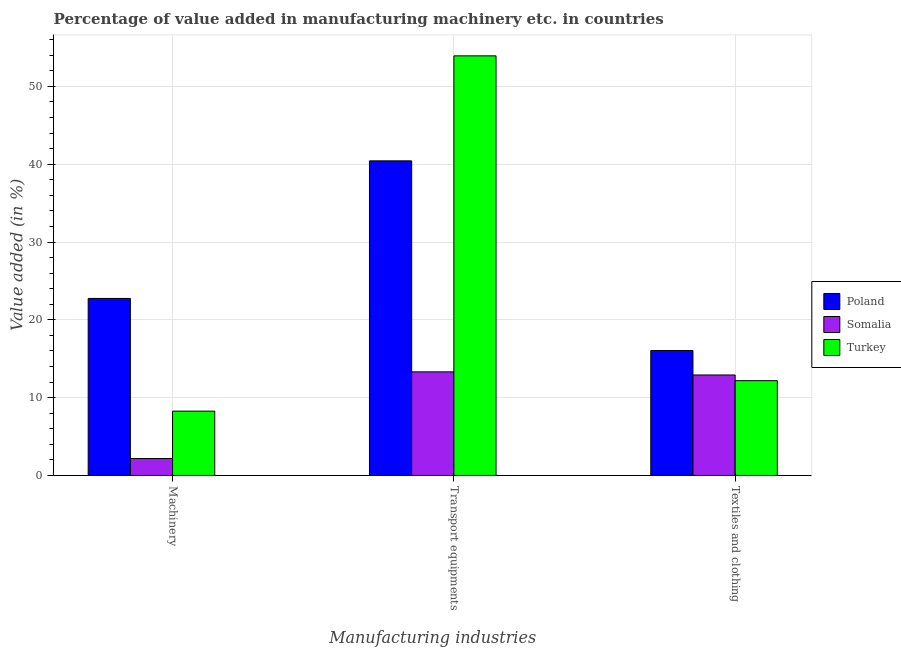Are the number of bars per tick equal to the number of legend labels?
Ensure brevity in your answer.  Yes. How many bars are there on the 3rd tick from the left?
Ensure brevity in your answer.  3. What is the label of the 3rd group of bars from the left?
Make the answer very short. Textiles and clothing. What is the value added in manufacturing machinery in Poland?
Your answer should be compact. 22.75. Across all countries, what is the maximum value added in manufacturing transport equipments?
Your answer should be compact. 53.93. Across all countries, what is the minimum value added in manufacturing transport equipments?
Give a very brief answer. 13.31. In which country was the value added in manufacturing transport equipments minimum?
Offer a terse response. Somalia. What is the total value added in manufacturing machinery in the graph?
Provide a succinct answer. 33.19. What is the difference between the value added in manufacturing transport equipments in Somalia and that in Poland?
Ensure brevity in your answer.  -27.12. What is the difference between the value added in manufacturing transport equipments in Poland and the value added in manufacturing machinery in Turkey?
Provide a succinct answer. 32.17. What is the average value added in manufacturing transport equipments per country?
Give a very brief answer. 35.89. What is the difference between the value added in manufacturing transport equipments and value added in manufacturing textile and clothing in Turkey?
Give a very brief answer. 41.75. In how many countries, is the value added in manufacturing transport equipments greater than 44 %?
Ensure brevity in your answer.  1. What is the ratio of the value added in manufacturing transport equipments in Poland to that in Turkey?
Offer a very short reply. 0.75. Is the value added in manufacturing machinery in Poland less than that in Somalia?
Offer a terse response. No. What is the difference between the highest and the second highest value added in manufacturing machinery?
Keep it short and to the point. 14.49. What is the difference between the highest and the lowest value added in manufacturing machinery?
Provide a short and direct response. 20.58. In how many countries, is the value added in manufacturing textile and clothing greater than the average value added in manufacturing textile and clothing taken over all countries?
Give a very brief answer. 1. What does the 3rd bar from the left in Transport equipments represents?
Your response must be concise. Turkey. What does the 2nd bar from the right in Textiles and clothing represents?
Offer a terse response. Somalia. Is it the case that in every country, the sum of the value added in manufacturing machinery and value added in manufacturing transport equipments is greater than the value added in manufacturing textile and clothing?
Provide a succinct answer. Yes. Are all the bars in the graph horizontal?
Your answer should be compact. No. What is the difference between two consecutive major ticks on the Y-axis?
Ensure brevity in your answer.  10. Does the graph contain grids?
Offer a very short reply. Yes. What is the title of the graph?
Provide a short and direct response. Percentage of value added in manufacturing machinery etc. in countries. What is the label or title of the X-axis?
Your answer should be compact. Manufacturing industries. What is the label or title of the Y-axis?
Your response must be concise. Value added (in %). What is the Value added (in %) of Poland in Machinery?
Give a very brief answer. 22.75. What is the Value added (in %) in Somalia in Machinery?
Your answer should be very brief. 2.17. What is the Value added (in %) in Turkey in Machinery?
Keep it short and to the point. 8.27. What is the Value added (in %) of Poland in Transport equipments?
Provide a short and direct response. 40.43. What is the Value added (in %) in Somalia in Transport equipments?
Ensure brevity in your answer.  13.31. What is the Value added (in %) in Turkey in Transport equipments?
Your response must be concise. 53.93. What is the Value added (in %) in Poland in Textiles and clothing?
Provide a succinct answer. 16.05. What is the Value added (in %) of Somalia in Textiles and clothing?
Give a very brief answer. 12.91. What is the Value added (in %) in Turkey in Textiles and clothing?
Keep it short and to the point. 12.18. Across all Manufacturing industries, what is the maximum Value added (in %) in Poland?
Your answer should be compact. 40.43. Across all Manufacturing industries, what is the maximum Value added (in %) of Somalia?
Your answer should be compact. 13.31. Across all Manufacturing industries, what is the maximum Value added (in %) in Turkey?
Make the answer very short. 53.93. Across all Manufacturing industries, what is the minimum Value added (in %) in Poland?
Provide a succinct answer. 16.05. Across all Manufacturing industries, what is the minimum Value added (in %) of Somalia?
Offer a terse response. 2.17. Across all Manufacturing industries, what is the minimum Value added (in %) in Turkey?
Ensure brevity in your answer.  8.27. What is the total Value added (in %) in Poland in the graph?
Ensure brevity in your answer.  79.24. What is the total Value added (in %) in Somalia in the graph?
Provide a short and direct response. 28.4. What is the total Value added (in %) in Turkey in the graph?
Keep it short and to the point. 74.37. What is the difference between the Value added (in %) of Poland in Machinery and that in Transport equipments?
Give a very brief answer. -17.68. What is the difference between the Value added (in %) of Somalia in Machinery and that in Transport equipments?
Give a very brief answer. -11.14. What is the difference between the Value added (in %) of Turkey in Machinery and that in Transport equipments?
Ensure brevity in your answer.  -45.66. What is the difference between the Value added (in %) in Poland in Machinery and that in Textiles and clothing?
Ensure brevity in your answer.  6.7. What is the difference between the Value added (in %) of Somalia in Machinery and that in Textiles and clothing?
Offer a very short reply. -10.74. What is the difference between the Value added (in %) of Turkey in Machinery and that in Textiles and clothing?
Provide a succinct answer. -3.91. What is the difference between the Value added (in %) of Poland in Transport equipments and that in Textiles and clothing?
Provide a short and direct response. 24.38. What is the difference between the Value added (in %) in Somalia in Transport equipments and that in Textiles and clothing?
Provide a succinct answer. 0.4. What is the difference between the Value added (in %) of Turkey in Transport equipments and that in Textiles and clothing?
Give a very brief answer. 41.75. What is the difference between the Value added (in %) of Poland in Machinery and the Value added (in %) of Somalia in Transport equipments?
Offer a very short reply. 9.44. What is the difference between the Value added (in %) in Poland in Machinery and the Value added (in %) in Turkey in Transport equipments?
Provide a succinct answer. -31.18. What is the difference between the Value added (in %) of Somalia in Machinery and the Value added (in %) of Turkey in Transport equipments?
Provide a succinct answer. -51.76. What is the difference between the Value added (in %) of Poland in Machinery and the Value added (in %) of Somalia in Textiles and clothing?
Keep it short and to the point. 9.84. What is the difference between the Value added (in %) of Poland in Machinery and the Value added (in %) of Turkey in Textiles and clothing?
Keep it short and to the point. 10.57. What is the difference between the Value added (in %) of Somalia in Machinery and the Value added (in %) of Turkey in Textiles and clothing?
Your answer should be very brief. -10.01. What is the difference between the Value added (in %) in Poland in Transport equipments and the Value added (in %) in Somalia in Textiles and clothing?
Your answer should be compact. 27.52. What is the difference between the Value added (in %) of Poland in Transport equipments and the Value added (in %) of Turkey in Textiles and clothing?
Provide a short and direct response. 28.25. What is the difference between the Value added (in %) of Somalia in Transport equipments and the Value added (in %) of Turkey in Textiles and clothing?
Keep it short and to the point. 1.13. What is the average Value added (in %) of Poland per Manufacturing industries?
Keep it short and to the point. 26.41. What is the average Value added (in %) in Somalia per Manufacturing industries?
Ensure brevity in your answer.  9.47. What is the average Value added (in %) in Turkey per Manufacturing industries?
Make the answer very short. 24.79. What is the difference between the Value added (in %) of Poland and Value added (in %) of Somalia in Machinery?
Ensure brevity in your answer.  20.58. What is the difference between the Value added (in %) in Poland and Value added (in %) in Turkey in Machinery?
Make the answer very short. 14.49. What is the difference between the Value added (in %) in Somalia and Value added (in %) in Turkey in Machinery?
Keep it short and to the point. -6.09. What is the difference between the Value added (in %) in Poland and Value added (in %) in Somalia in Transport equipments?
Your answer should be compact. 27.12. What is the difference between the Value added (in %) in Poland and Value added (in %) in Turkey in Transport equipments?
Give a very brief answer. -13.49. What is the difference between the Value added (in %) in Somalia and Value added (in %) in Turkey in Transport equipments?
Your response must be concise. -40.61. What is the difference between the Value added (in %) of Poland and Value added (in %) of Somalia in Textiles and clothing?
Offer a very short reply. 3.14. What is the difference between the Value added (in %) of Poland and Value added (in %) of Turkey in Textiles and clothing?
Your response must be concise. 3.87. What is the difference between the Value added (in %) in Somalia and Value added (in %) in Turkey in Textiles and clothing?
Provide a succinct answer. 0.73. What is the ratio of the Value added (in %) of Poland in Machinery to that in Transport equipments?
Make the answer very short. 0.56. What is the ratio of the Value added (in %) of Somalia in Machinery to that in Transport equipments?
Ensure brevity in your answer.  0.16. What is the ratio of the Value added (in %) of Turkey in Machinery to that in Transport equipments?
Provide a short and direct response. 0.15. What is the ratio of the Value added (in %) in Poland in Machinery to that in Textiles and clothing?
Offer a very short reply. 1.42. What is the ratio of the Value added (in %) of Somalia in Machinery to that in Textiles and clothing?
Your answer should be compact. 0.17. What is the ratio of the Value added (in %) of Turkey in Machinery to that in Textiles and clothing?
Ensure brevity in your answer.  0.68. What is the ratio of the Value added (in %) of Poland in Transport equipments to that in Textiles and clothing?
Make the answer very short. 2.52. What is the ratio of the Value added (in %) of Somalia in Transport equipments to that in Textiles and clothing?
Provide a succinct answer. 1.03. What is the ratio of the Value added (in %) in Turkey in Transport equipments to that in Textiles and clothing?
Keep it short and to the point. 4.43. What is the difference between the highest and the second highest Value added (in %) in Poland?
Offer a very short reply. 17.68. What is the difference between the highest and the second highest Value added (in %) of Somalia?
Your answer should be very brief. 0.4. What is the difference between the highest and the second highest Value added (in %) of Turkey?
Your response must be concise. 41.75. What is the difference between the highest and the lowest Value added (in %) in Poland?
Keep it short and to the point. 24.38. What is the difference between the highest and the lowest Value added (in %) in Somalia?
Keep it short and to the point. 11.14. What is the difference between the highest and the lowest Value added (in %) in Turkey?
Offer a terse response. 45.66. 